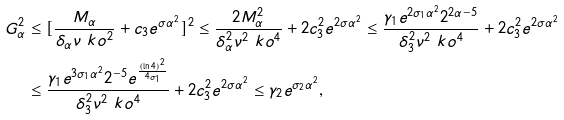<formula> <loc_0><loc_0><loc_500><loc_500>G ^ { 2 } _ { \alpha } & \leq [ \frac { M _ { \alpha } } { \delta _ { \alpha } \nu \ k o ^ { 2 } } + c _ { 3 } e ^ { \sigma \alpha ^ { 2 } } ] ^ { 2 } \leq \frac { 2 M ^ { 2 } _ { \alpha } } { \delta ^ { 2 } _ { \alpha } \nu ^ { 2 } \ k o ^ { 4 } } + 2 c _ { 3 } ^ { 2 } e ^ { 2 \sigma \alpha ^ { 2 } } \leq \frac { \gamma _ { 1 } e ^ { 2 \sigma _ { 1 } \alpha ^ { 2 } } 2 ^ { 2 \alpha - 5 } } { \delta ^ { 2 } _ { 3 } \nu ^ { 2 } \ k o ^ { 4 } } + 2 c _ { 3 } ^ { 2 } e ^ { 2 \sigma \alpha ^ { 2 } } \\ & \leq \frac { \gamma _ { 1 } e ^ { 3 \sigma _ { 1 } \alpha ^ { 2 } } 2 ^ { - 5 } e ^ { \frac { ( \ln 4 ) ^ { 2 } } { 4 \sigma _ { 1 } } } } { \delta ^ { 2 } _ { 3 } \nu ^ { 2 } \ k o ^ { 4 } } + 2 c _ { 3 } ^ { 2 } e ^ { 2 \sigma \alpha ^ { 2 } } \leq \gamma _ { 2 } e ^ { \sigma _ { 2 } \alpha ^ { 2 } } ,</formula> 